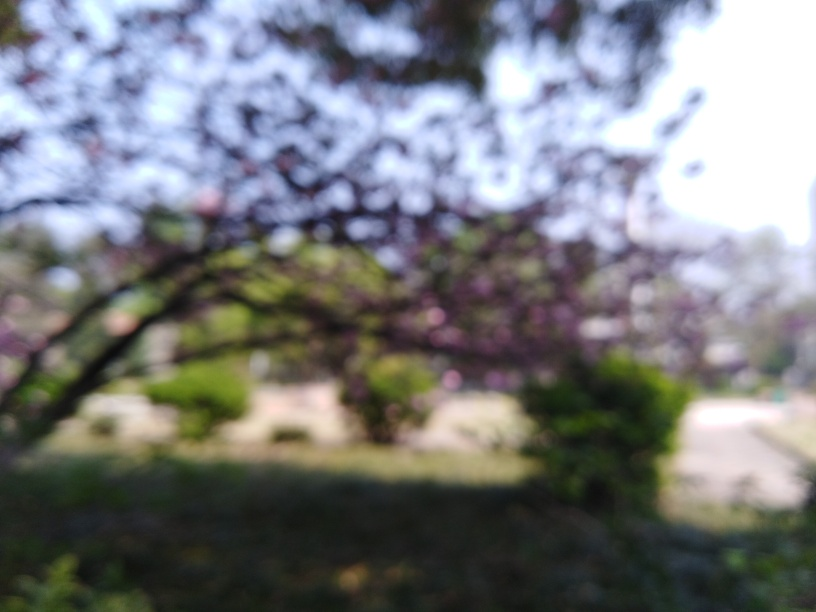Could the setting have any particular significance or evoke certain emotions? The image could evoke a sense of mystery or calmness due to its dreamy, unclear appearance. It might represent a personal memory, a moment of tranquility, or the fleeting nature of a certain time or season, such as the brief blooming period of cherry blossoms. 